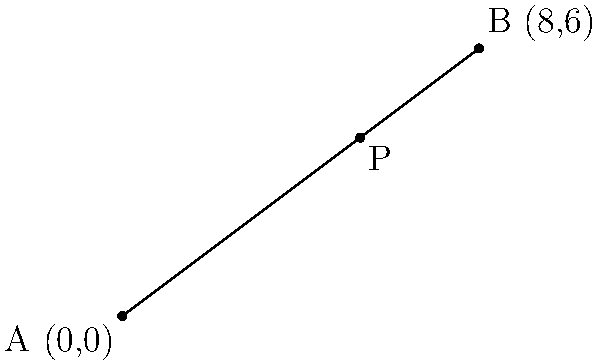As a talent acquisition manager, you're planning to relocate two team members for an international project. Team member A is currently at coordinates (0,0), and team member B is at (8,6). You want to place a new office at point P, which divides the line segment AB in the ratio 1:2. Calculate the coordinates of point P. To find the coordinates of point P that divides the line segment AB in the ratio 1:2, we can use the section formula:

1. Let the coordinates of point P be $(x,y)$.

2. The section formula states:
   $x = \frac{m x_2 + n x_1}{m + n}$ and $y = \frac{m y_2 + n y_1}{m + n}$

   Where $(x_1, y_1)$ are the coordinates of A, $(x_2, y_2)$ are the coordinates of B, and $m:n$ is the ratio in which P divides AB.

3. In this case:
   $(x_1, y_1) = (0, 0)$
   $(x_2, y_2) = (8, 6)$
   $m:n = 2:1$

4. Substituting into the formula:
   $x = \frac{2(8) + 1(0)}{2 + 1} = \frac{16}{3}$
   $y = \frac{2(6) + 1(0)}{2 + 1} = \frac{12}{3} = 4$

5. Therefore, the coordinates of point P are $(\frac{16}{3}, 4)$.
Answer: $(\frac{16}{3}, 4)$ 